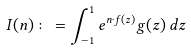Convert formula to latex. <formula><loc_0><loc_0><loc_500><loc_500>I ( n ) \colon = \int _ { - 1 } ^ { 1 } e ^ { n \cdot f ( z ) } g ( z ) \, d z</formula> 